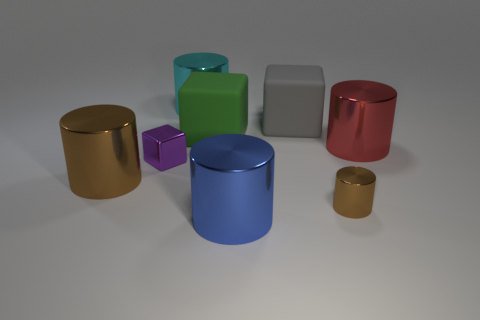Subtract all blue spheres. How many brown cylinders are left? 2 Subtract 1 blocks. How many blocks are left? 2 Subtract all blue cylinders. How many cylinders are left? 4 Subtract all brown metallic cylinders. How many cylinders are left? 3 Add 1 big green rubber cylinders. How many objects exist? 9 Subtract all cyan cylinders. Subtract all brown cubes. How many cylinders are left? 4 Subtract all cubes. How many objects are left? 5 Add 5 small blocks. How many small blocks are left? 6 Add 3 yellow cylinders. How many yellow cylinders exist? 3 Subtract 0 blue blocks. How many objects are left? 8 